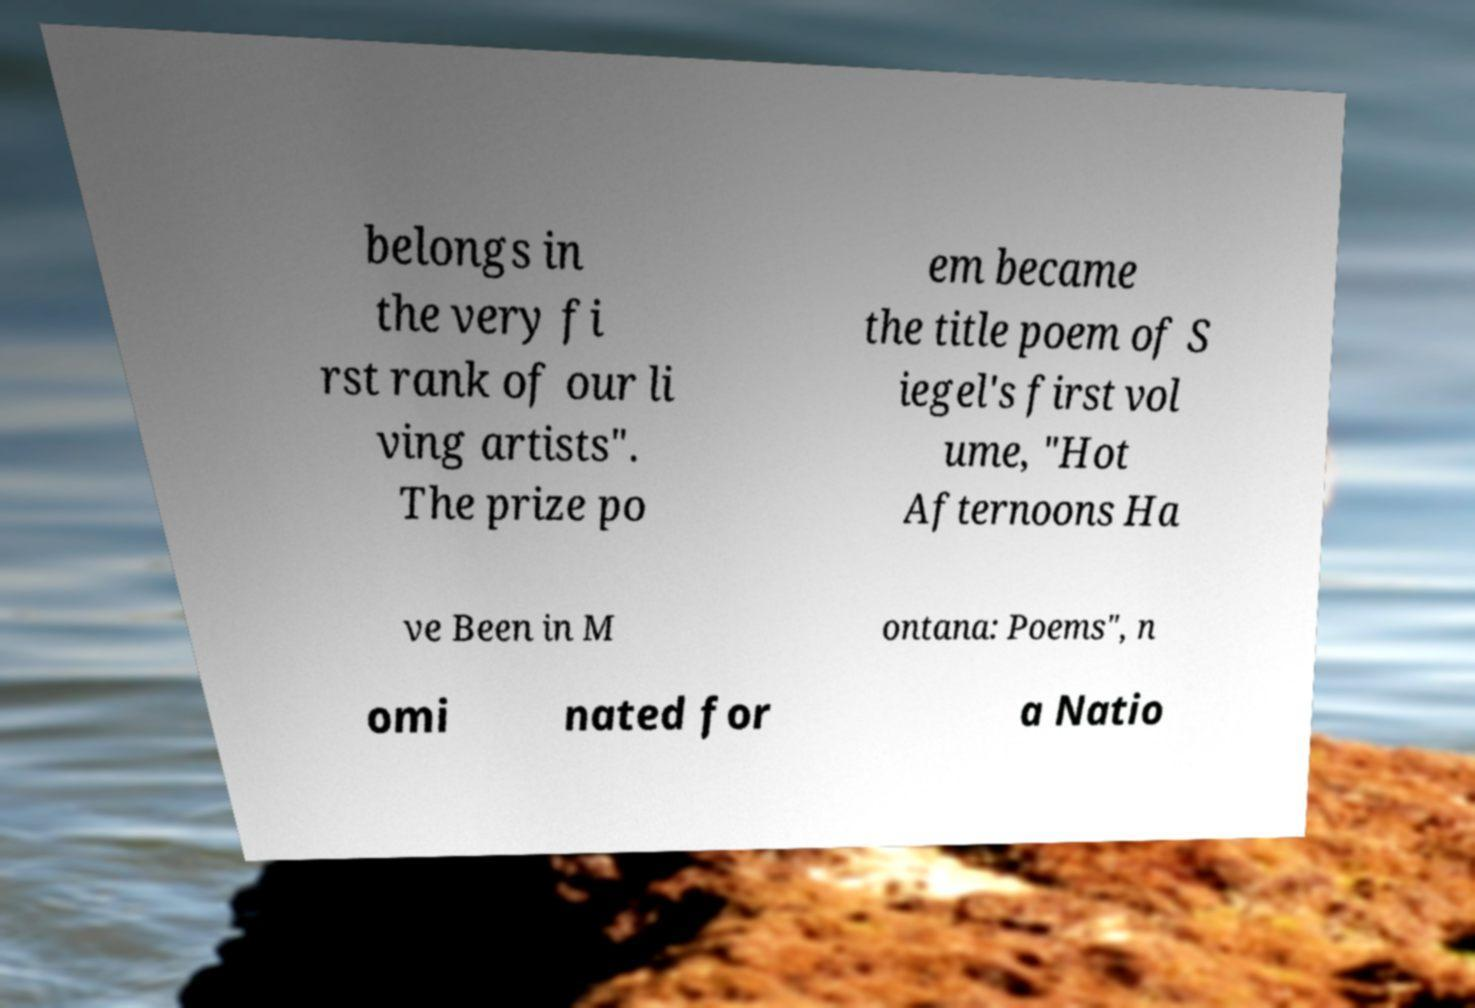What messages or text are displayed in this image? I need them in a readable, typed format. belongs in the very fi rst rank of our li ving artists". The prize po em became the title poem of S iegel's first vol ume, "Hot Afternoons Ha ve Been in M ontana: Poems", n omi nated for a Natio 